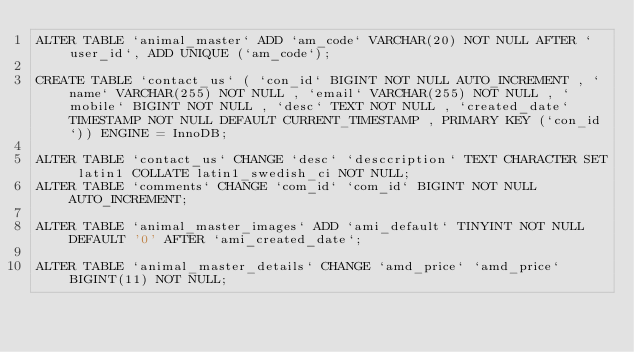<code> <loc_0><loc_0><loc_500><loc_500><_SQL_>ALTER TABLE `animal_master` ADD `am_code` VARCHAR(20) NOT NULL AFTER `user_id`, ADD UNIQUE (`am_code`);

CREATE TABLE `contact_us` ( `con_id` BIGINT NOT NULL AUTO_INCREMENT , `name` VARCHAR(255) NOT NULL , `email` VARCHAR(255) NOT NULL , `mobile` BIGINT NOT NULL , `desc` TEXT NOT NULL , `created_date` TIMESTAMP NOT NULL DEFAULT CURRENT_TIMESTAMP , PRIMARY KEY (`con_id`)) ENGINE = InnoDB;

ALTER TABLE `contact_us` CHANGE `desc` `desccription` TEXT CHARACTER SET latin1 COLLATE latin1_swedish_ci NOT NULL;
ALTER TABLE `comments` CHANGE `com_id` `com_id` BIGINT NOT NULL AUTO_INCREMENT;

ALTER TABLE `animal_master_images` ADD `ami_default` TINYINT NOT NULL DEFAULT '0' AFTER `ami_created_date`;

ALTER TABLE `animal_master_details` CHANGE `amd_price` `amd_price` BIGINT(11) NOT NULL;</code> 